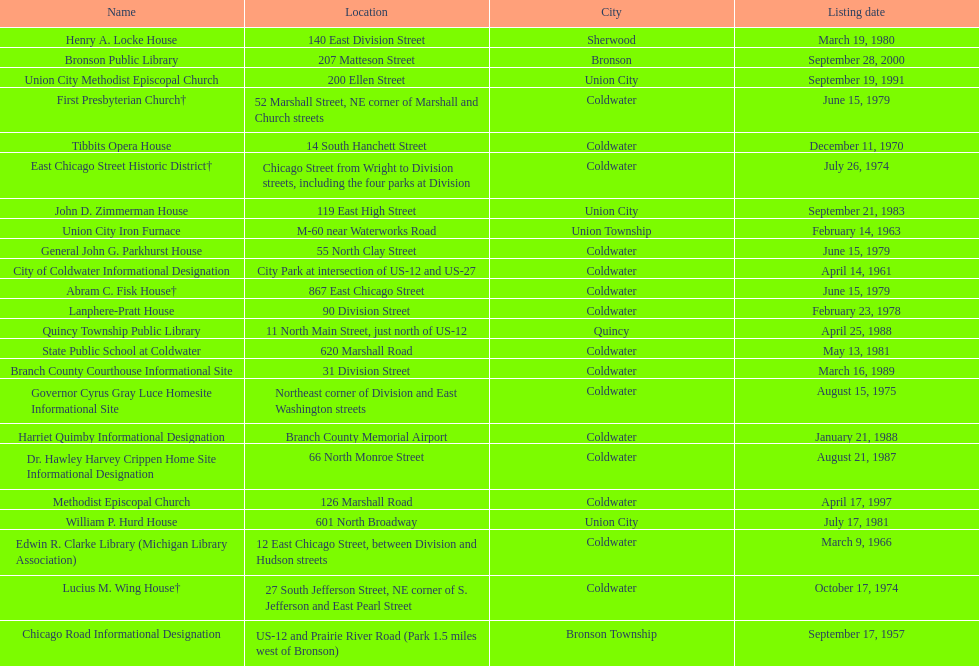How many sites were listed as historical before 1980? 12. 